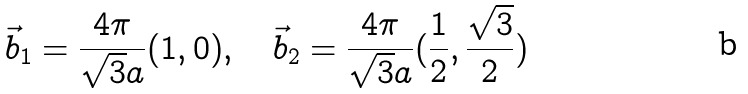Convert formula to latex. <formula><loc_0><loc_0><loc_500><loc_500>\vec { b } _ { 1 } = \frac { 4 \pi } { \sqrt { 3 } a } ( 1 , 0 ) , \quad \vec { b } _ { 2 } = \frac { 4 \pi } { \sqrt { 3 } a } ( \frac { 1 } { 2 } , \frac { \sqrt { 3 } } { 2 } )</formula> 